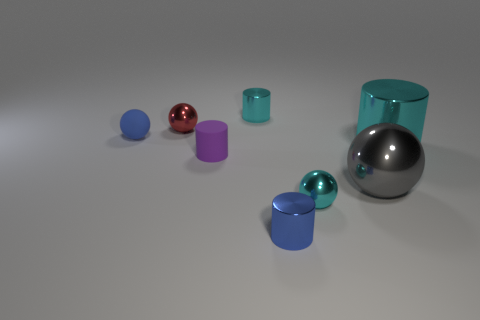There is a cyan cylinder in front of the red metal thing; does it have the same size as the tiny blue sphere?
Give a very brief answer. No. How many objects are either purple cylinders or small red metal balls?
Offer a terse response. 2. What is the cyan cylinder behind the small shiny sphere to the left of the cyan shiny cylinder left of the big cyan thing made of?
Ensure brevity in your answer.  Metal. There is a tiny cylinder that is in front of the tiny purple object; what material is it?
Your response must be concise. Metal. Is there a cyan shiny thing of the same size as the cyan shiny sphere?
Provide a succinct answer. Yes. Is the color of the metal sphere left of the tiny blue shiny thing the same as the matte cylinder?
Make the answer very short. No. How many cyan things are either tiny things or tiny metal spheres?
Offer a terse response. 2. What number of cylinders have the same color as the small rubber ball?
Ensure brevity in your answer.  1. Does the small purple object have the same material as the red ball?
Offer a very short reply. No. What number of gray spheres are to the left of the small purple matte cylinder that is on the left side of the gray ball?
Your answer should be very brief. 0. 